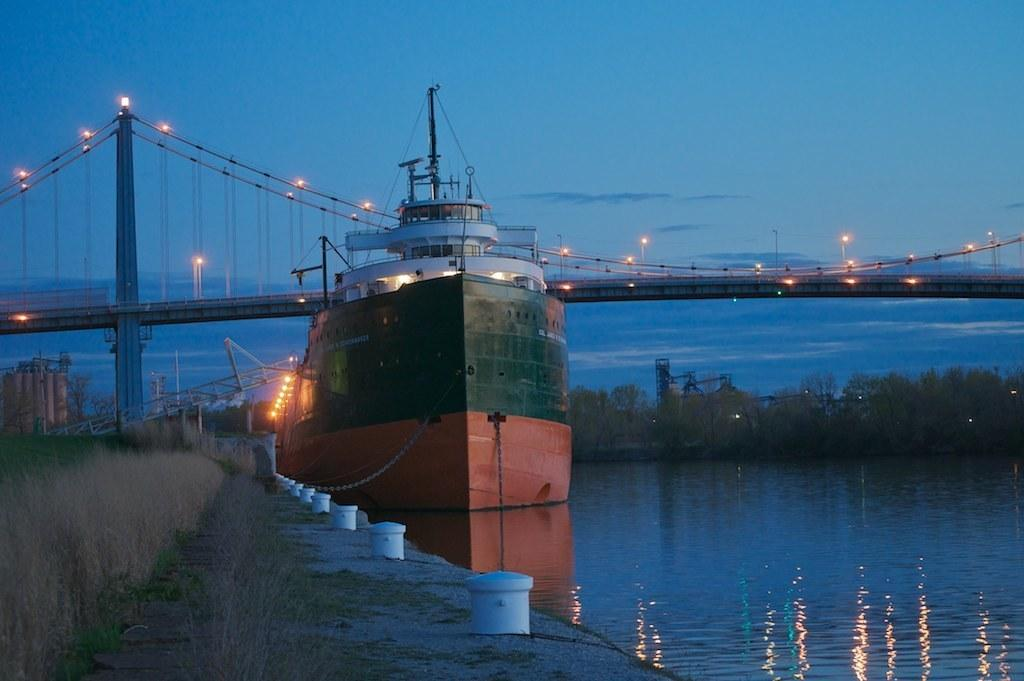What is the main subject of the image? The main subject of the image is a ship. Where is the ship located in the image? The ship is on the water in the image. What type of vegetation can be seen in the image? There are plants and grass visible in the image. What type of structure is present in the image? There is a bridge in the image. What type of illumination is present in the image? There are lights visible in the image. What else can be seen in the image besides the ship and the bridge? There are some objects and the sky is visible in the background of the image. What type of chess piece is depicted on the ship in the image? There is no chess piece present on the ship in the image. What type of learning material can be seen on the bridge in the image? There is no learning material present on the bridge in the image. 